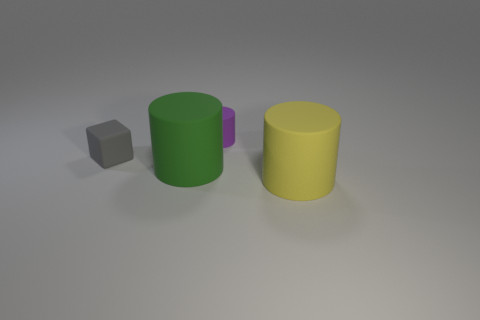Do the big object that is left of the large yellow thing and the small matte block have the same color?
Provide a short and direct response. No. There is a matte cylinder to the right of the small purple matte thing; how big is it?
Give a very brief answer. Large. What is the shape of the big green matte thing in front of the tiny matte object left of the small rubber cylinder?
Keep it short and to the point. Cylinder. There is another big thing that is the same shape as the yellow matte thing; what is its color?
Your answer should be compact. Green. Is the size of the rubber cylinder left of the purple matte object the same as the gray rubber object?
Provide a short and direct response. No. What number of tiny cylinders are the same material as the cube?
Your answer should be compact. 1. What is the material of the purple thing that is right of the large object left of the large thing that is in front of the green cylinder?
Ensure brevity in your answer.  Rubber. There is a big object that is in front of the large rubber cylinder left of the big yellow matte cylinder; what color is it?
Your answer should be compact. Yellow. What is the color of the rubber cylinder that is the same size as the gray cube?
Keep it short and to the point. Purple. How many tiny things are either purple cylinders or gray matte things?
Give a very brief answer. 2. 